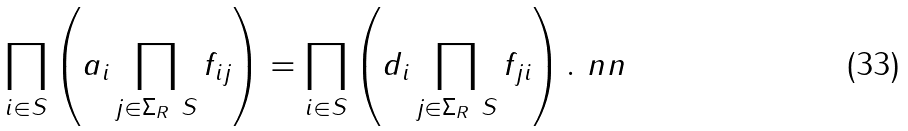<formula> <loc_0><loc_0><loc_500><loc_500>& \prod _ { i \in S } \left ( a _ { i } \prod _ { j \in \Sigma _ { R } \ S } f _ { i j } \right ) = \prod _ { i \in S } \left ( d _ { i } \prod _ { j \in \Sigma _ { R } \ S } f _ { j i } \right ) . \ n n</formula> 